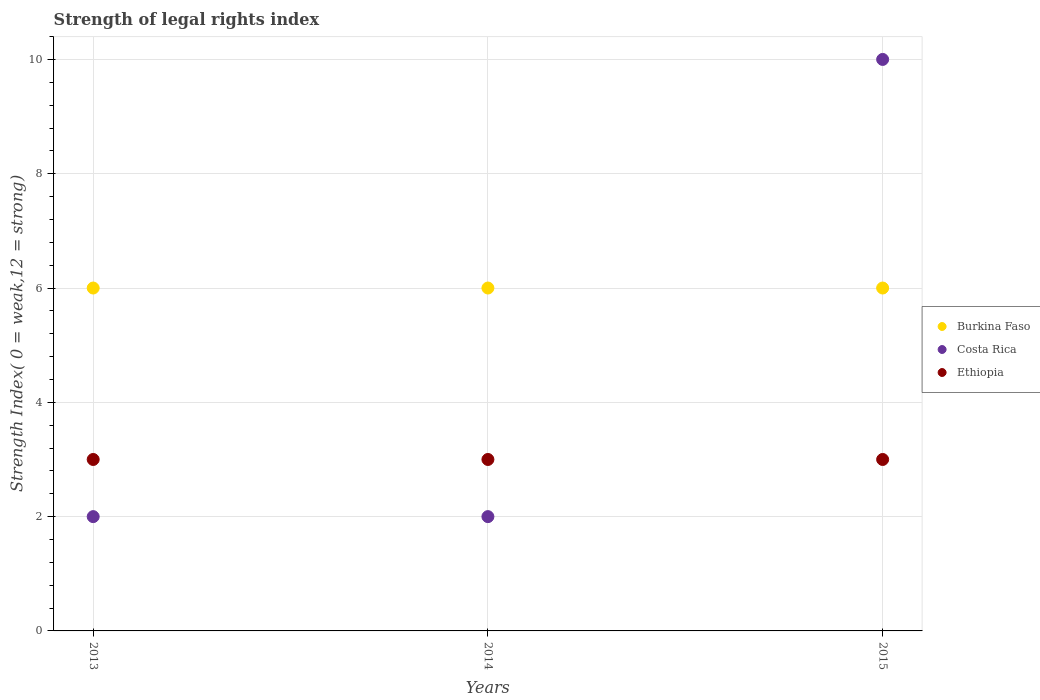How many different coloured dotlines are there?
Your answer should be compact. 3. What is the strength index in Ethiopia in 2013?
Provide a short and direct response. 3. Across all years, what is the maximum strength index in Costa Rica?
Provide a succinct answer. 10. Across all years, what is the minimum strength index in Costa Rica?
Make the answer very short. 2. In which year was the strength index in Burkina Faso maximum?
Give a very brief answer. 2013. In which year was the strength index in Costa Rica minimum?
Offer a very short reply. 2013. What is the total strength index in Ethiopia in the graph?
Ensure brevity in your answer.  9. What is the difference between the strength index in Burkina Faso in 2013 and that in 2015?
Make the answer very short. 0. What is the difference between the strength index in Ethiopia in 2015 and the strength index in Burkina Faso in 2014?
Your answer should be very brief. -3. In the year 2014, what is the difference between the strength index in Costa Rica and strength index in Burkina Faso?
Make the answer very short. -4. In how many years, is the strength index in Costa Rica greater than 6.4?
Make the answer very short. 1. What is the ratio of the strength index in Burkina Faso in 2014 to that in 2015?
Offer a very short reply. 1. Is the strength index in Costa Rica in 2013 less than that in 2015?
Ensure brevity in your answer.  Yes. What is the difference between the highest and the second highest strength index in Ethiopia?
Offer a terse response. 0. What is the difference between the highest and the lowest strength index in Burkina Faso?
Keep it short and to the point. 0. In how many years, is the strength index in Costa Rica greater than the average strength index in Costa Rica taken over all years?
Give a very brief answer. 1. Is the sum of the strength index in Ethiopia in 2013 and 2014 greater than the maximum strength index in Burkina Faso across all years?
Offer a very short reply. No. Is it the case that in every year, the sum of the strength index in Ethiopia and strength index in Burkina Faso  is greater than the strength index in Costa Rica?
Your answer should be very brief. No. Does the strength index in Burkina Faso monotonically increase over the years?
Keep it short and to the point. No. Is the strength index in Costa Rica strictly less than the strength index in Burkina Faso over the years?
Give a very brief answer. No. Are the values on the major ticks of Y-axis written in scientific E-notation?
Make the answer very short. No. Does the graph contain any zero values?
Provide a succinct answer. No. Does the graph contain grids?
Give a very brief answer. Yes. How many legend labels are there?
Ensure brevity in your answer.  3. How are the legend labels stacked?
Give a very brief answer. Vertical. What is the title of the graph?
Your response must be concise. Strength of legal rights index. Does "Slovak Republic" appear as one of the legend labels in the graph?
Offer a very short reply. No. What is the label or title of the Y-axis?
Your answer should be compact. Strength Index( 0 = weak,12 = strong). What is the Strength Index( 0 = weak,12 = strong) in Costa Rica in 2013?
Ensure brevity in your answer.  2. What is the Strength Index( 0 = weak,12 = strong) of Burkina Faso in 2014?
Your response must be concise. 6. What is the Strength Index( 0 = weak,12 = strong) in Burkina Faso in 2015?
Your answer should be compact. 6. What is the Strength Index( 0 = weak,12 = strong) in Costa Rica in 2015?
Ensure brevity in your answer.  10. What is the Strength Index( 0 = weak,12 = strong) of Ethiopia in 2015?
Make the answer very short. 3. Across all years, what is the maximum Strength Index( 0 = weak,12 = strong) in Burkina Faso?
Ensure brevity in your answer.  6. Across all years, what is the maximum Strength Index( 0 = weak,12 = strong) of Costa Rica?
Your answer should be very brief. 10. Across all years, what is the maximum Strength Index( 0 = weak,12 = strong) in Ethiopia?
Your answer should be compact. 3. What is the total Strength Index( 0 = weak,12 = strong) in Costa Rica in the graph?
Your answer should be very brief. 14. What is the total Strength Index( 0 = weak,12 = strong) of Ethiopia in the graph?
Give a very brief answer. 9. What is the difference between the Strength Index( 0 = weak,12 = strong) in Burkina Faso in 2013 and that in 2014?
Offer a very short reply. 0. What is the difference between the Strength Index( 0 = weak,12 = strong) of Costa Rica in 2013 and that in 2014?
Your answer should be very brief. 0. What is the difference between the Strength Index( 0 = weak,12 = strong) of Costa Rica in 2013 and that in 2015?
Make the answer very short. -8. What is the difference between the Strength Index( 0 = weak,12 = strong) of Ethiopia in 2014 and that in 2015?
Provide a short and direct response. 0. What is the difference between the Strength Index( 0 = weak,12 = strong) in Burkina Faso in 2013 and the Strength Index( 0 = weak,12 = strong) in Costa Rica in 2015?
Provide a succinct answer. -4. What is the difference between the Strength Index( 0 = weak,12 = strong) in Burkina Faso in 2014 and the Strength Index( 0 = weak,12 = strong) in Costa Rica in 2015?
Provide a short and direct response. -4. What is the average Strength Index( 0 = weak,12 = strong) in Burkina Faso per year?
Offer a terse response. 6. What is the average Strength Index( 0 = weak,12 = strong) of Costa Rica per year?
Provide a short and direct response. 4.67. What is the average Strength Index( 0 = weak,12 = strong) in Ethiopia per year?
Make the answer very short. 3. In the year 2013, what is the difference between the Strength Index( 0 = weak,12 = strong) of Costa Rica and Strength Index( 0 = weak,12 = strong) of Ethiopia?
Give a very brief answer. -1. In the year 2014, what is the difference between the Strength Index( 0 = weak,12 = strong) in Burkina Faso and Strength Index( 0 = weak,12 = strong) in Costa Rica?
Keep it short and to the point. 4. In the year 2014, what is the difference between the Strength Index( 0 = weak,12 = strong) of Burkina Faso and Strength Index( 0 = weak,12 = strong) of Ethiopia?
Offer a terse response. 3. In the year 2014, what is the difference between the Strength Index( 0 = weak,12 = strong) of Costa Rica and Strength Index( 0 = weak,12 = strong) of Ethiopia?
Make the answer very short. -1. In the year 2015, what is the difference between the Strength Index( 0 = weak,12 = strong) in Burkina Faso and Strength Index( 0 = weak,12 = strong) in Costa Rica?
Offer a very short reply. -4. In the year 2015, what is the difference between the Strength Index( 0 = weak,12 = strong) of Costa Rica and Strength Index( 0 = weak,12 = strong) of Ethiopia?
Provide a short and direct response. 7. What is the ratio of the Strength Index( 0 = weak,12 = strong) in Burkina Faso in 2013 to that in 2014?
Your response must be concise. 1. What is the ratio of the Strength Index( 0 = weak,12 = strong) of Burkina Faso in 2013 to that in 2015?
Offer a very short reply. 1. What is the ratio of the Strength Index( 0 = weak,12 = strong) in Costa Rica in 2013 to that in 2015?
Offer a very short reply. 0.2. What is the ratio of the Strength Index( 0 = weak,12 = strong) of Ethiopia in 2013 to that in 2015?
Offer a terse response. 1. What is the ratio of the Strength Index( 0 = weak,12 = strong) of Burkina Faso in 2014 to that in 2015?
Provide a short and direct response. 1. What is the ratio of the Strength Index( 0 = weak,12 = strong) of Ethiopia in 2014 to that in 2015?
Provide a succinct answer. 1. What is the difference between the highest and the second highest Strength Index( 0 = weak,12 = strong) in Costa Rica?
Your answer should be very brief. 8. What is the difference between the highest and the second highest Strength Index( 0 = weak,12 = strong) of Ethiopia?
Ensure brevity in your answer.  0. What is the difference between the highest and the lowest Strength Index( 0 = weak,12 = strong) of Ethiopia?
Your answer should be very brief. 0. 